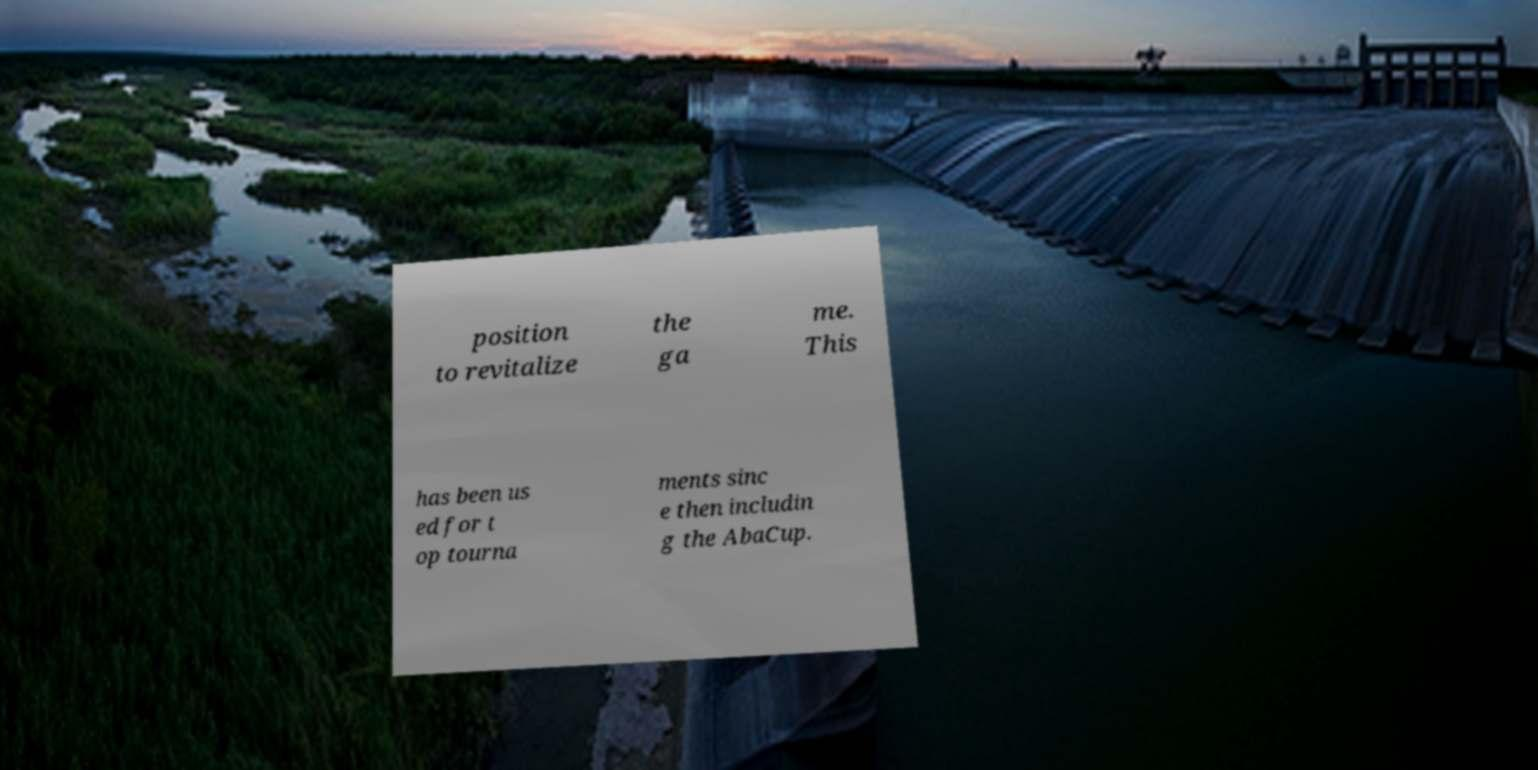Could you extract and type out the text from this image? position to revitalize the ga me. This has been us ed for t op tourna ments sinc e then includin g the AbaCup. 